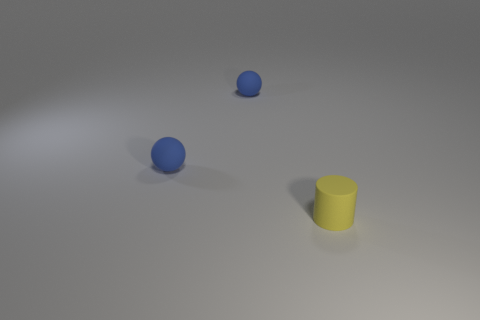Add 2 yellow rubber cylinders. How many objects exist? 5 Subtract all spheres. How many objects are left? 1 Subtract 1 spheres. How many spheres are left? 1 Add 2 small spheres. How many small spheres exist? 4 Subtract 0 cyan cylinders. How many objects are left? 3 Subtract all cyan cylinders. Subtract all purple balls. How many cylinders are left? 1 Subtract all tiny cylinders. Subtract all blue balls. How many objects are left? 0 Add 3 tiny yellow rubber cylinders. How many tiny yellow rubber cylinders are left? 4 